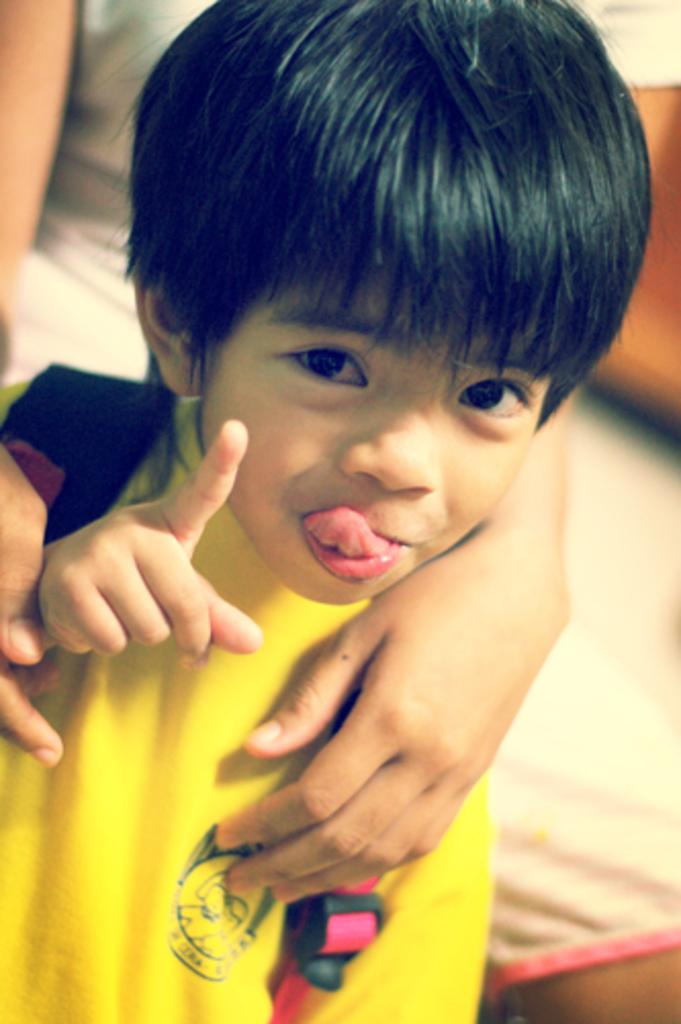Who is the main subject in the image? There is a boy in the image. What is the boy wearing? The boy is wearing a yellow t-shirt. Can you describe the other person in the image? There is a person sitting in the image. What is the person doing with the boy? The person is holding the boy. What are the boy's hobbies, as depicted in the image? The image does not provide information about the boy's hobbies. Can you tell me how many goats are present in the image? There are no goats present in the image. 